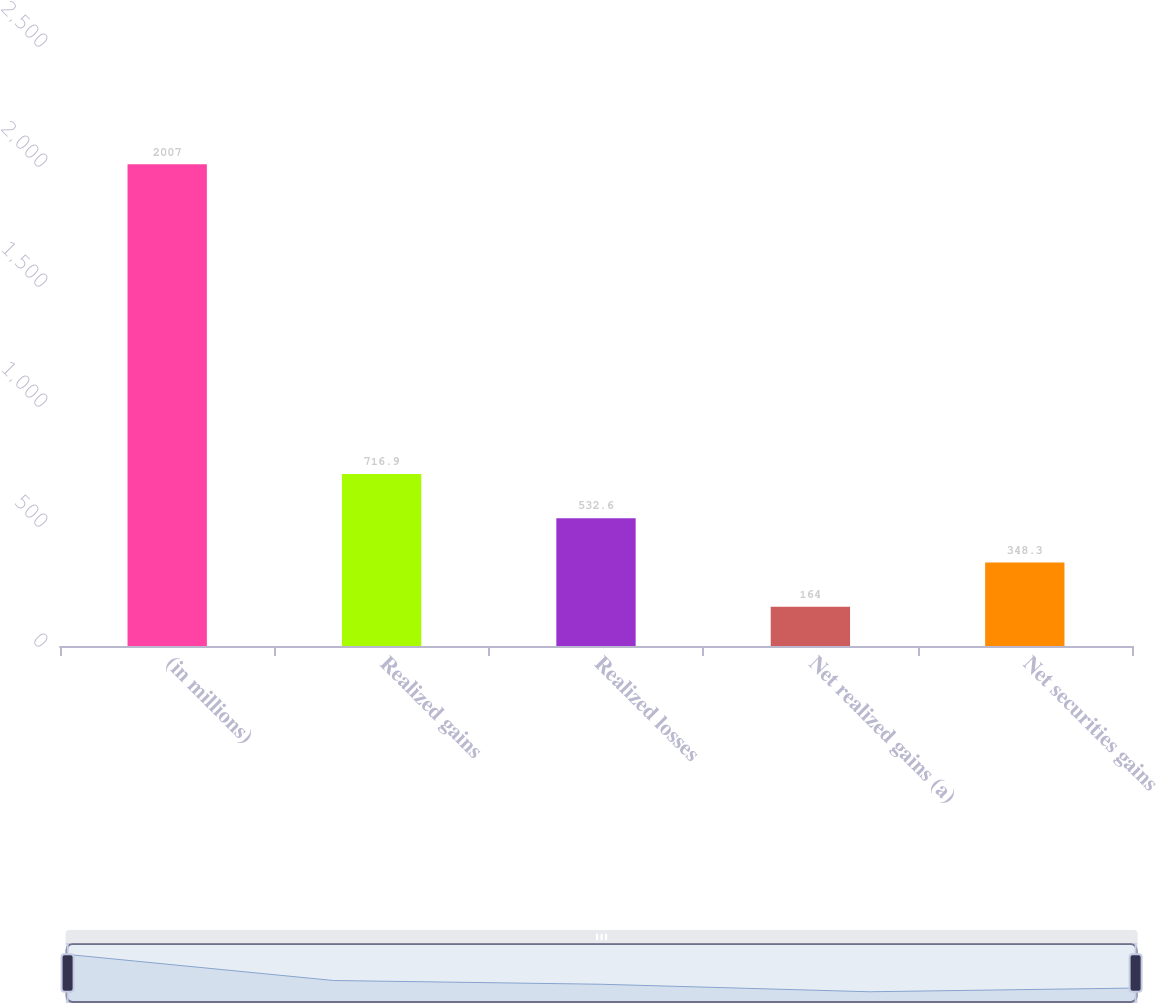<chart> <loc_0><loc_0><loc_500><loc_500><bar_chart><fcel>(in millions)<fcel>Realized gains<fcel>Realized losses<fcel>Net realized gains (a)<fcel>Net securities gains<nl><fcel>2007<fcel>716.9<fcel>532.6<fcel>164<fcel>348.3<nl></chart> 